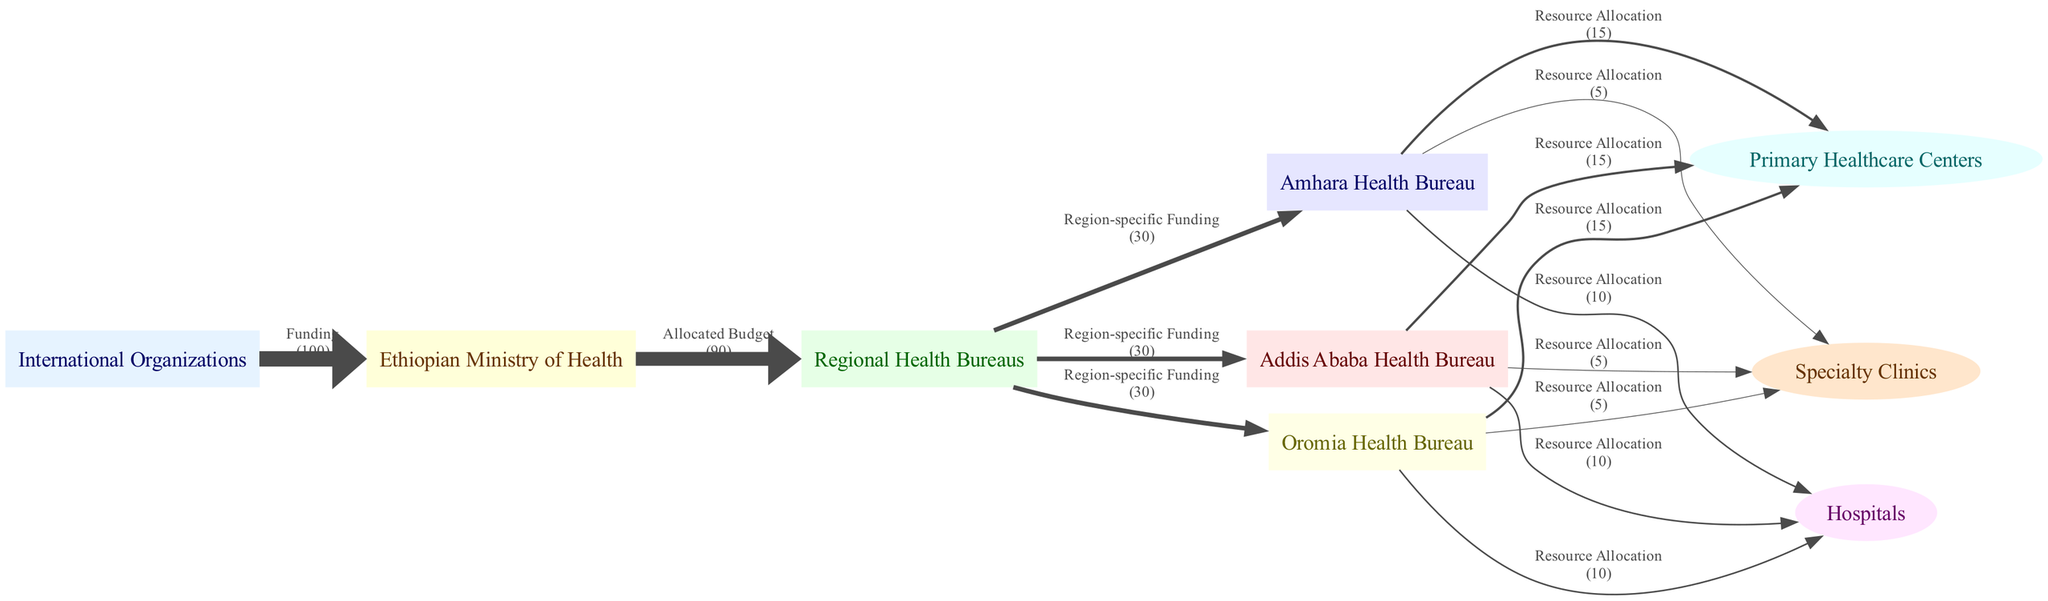What is the total funding from International Organizations? Referring to the diagram, the total funding from International Organizations to the Ethiopian Ministry of Health is indicated as 100.
Answer: 100 How many Regional Health Bureaus are represented in the diagram? The nodes labeled 'Regional Health Bureaus' can be counted in the diagram; there are three specific bureaus listed: Amhara, Oromia, and the Addis Ababa Health Bureau, making a total of three.
Answer: 3 What resource allocation amount is directed to Hospitals from Addis Ababa Health Bureau? The diagram shows that the resource allocation amount directed to Hospitals from the Addis Ababa Health Bureau is indicated as 10.
Answer: 10 Which healthcare facilities receive a total of 15 in resource allocation from Oromia Health Bureau? The diagram denotes that Primary Healthcare Centers receive 15 from Oromia Health Bureau; thus, this is the only healthcare facility that matches this allocation.
Answer: Primary Healthcare Centers What is the total amount of resources allocated to Specialty Clinics from all Regional Health Bureaus combined? By examining the flows from each of the three Regional Health Bureaus in the diagram, the total allocations to Specialty Clinics are: 5 from Addis Ababa, 5 from Amhara, and 5 from Oromia, resulting in a combined total of 15.
Answer: 15 How does the funding from the Ethiopian Ministry of Health distribute among the Regional Health Bureaus? The Ethiopian Ministry of Health allocates a total of 90 among the three Regional Health Bureaus, specifically 30 to each of Addis Ababa, Amhara, and Oromia, which distributes evenly among them.
Answer: 30 each What is the relationship between International Organizations and the Ethiopian Ministry of Health? In the diagram, the relationship is shown as funding, where International Organizations provide funding to the Ethiopian Ministry of Health.
Answer: Funding Which type of diagram is used to represent the flow and distribution of resources in this context? The diagram type illustrated is a Sankey Diagram, known for clearly displaying the flow of resources and various allocations.
Answer: Sankey Diagram 